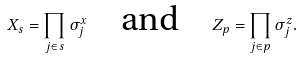<formula> <loc_0><loc_0><loc_500><loc_500>X _ { s } = \prod _ { j \in s } \sigma _ { j } ^ { x } \quad \text {and} \quad Z _ { p } = \prod _ { j \in p } \sigma _ { j } ^ { z } .</formula> 